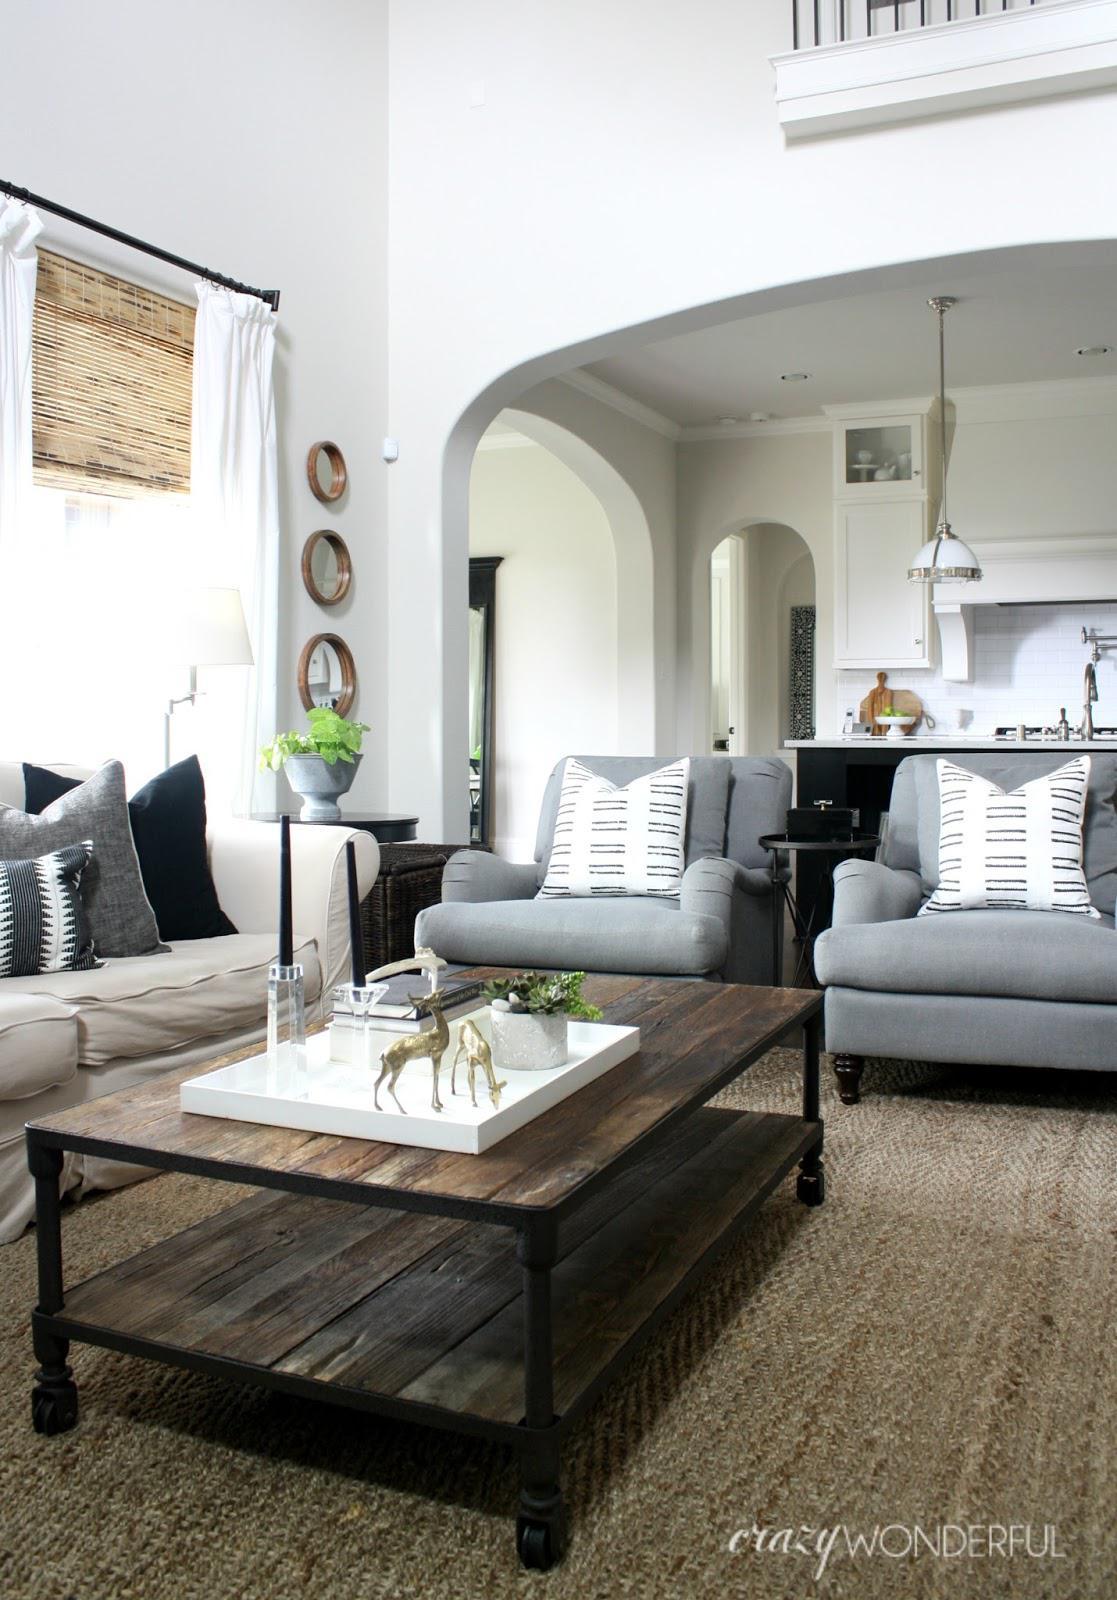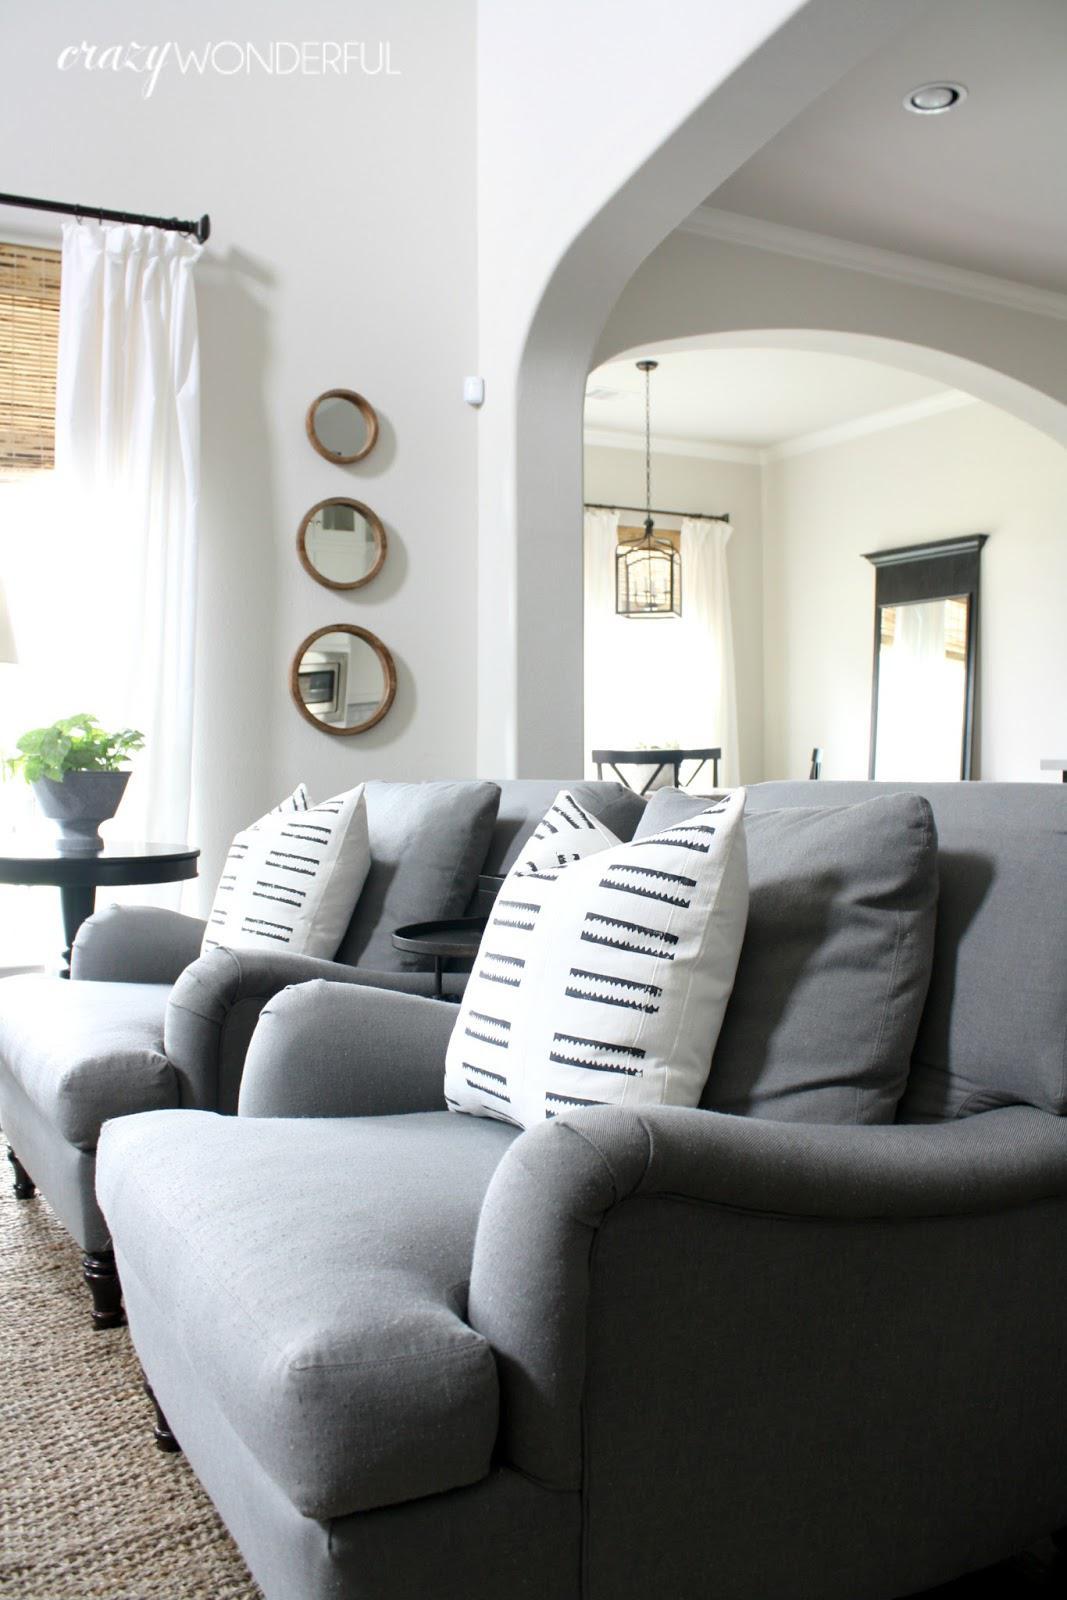The first image is the image on the left, the second image is the image on the right. Considering the images on both sides, is "There is a person sitting on a couch." valid? Answer yes or no. No. The first image is the image on the left, the second image is the image on the right. For the images displayed, is the sentence "An image contains a person sitting on a couch." factually correct? Answer yes or no. No. 